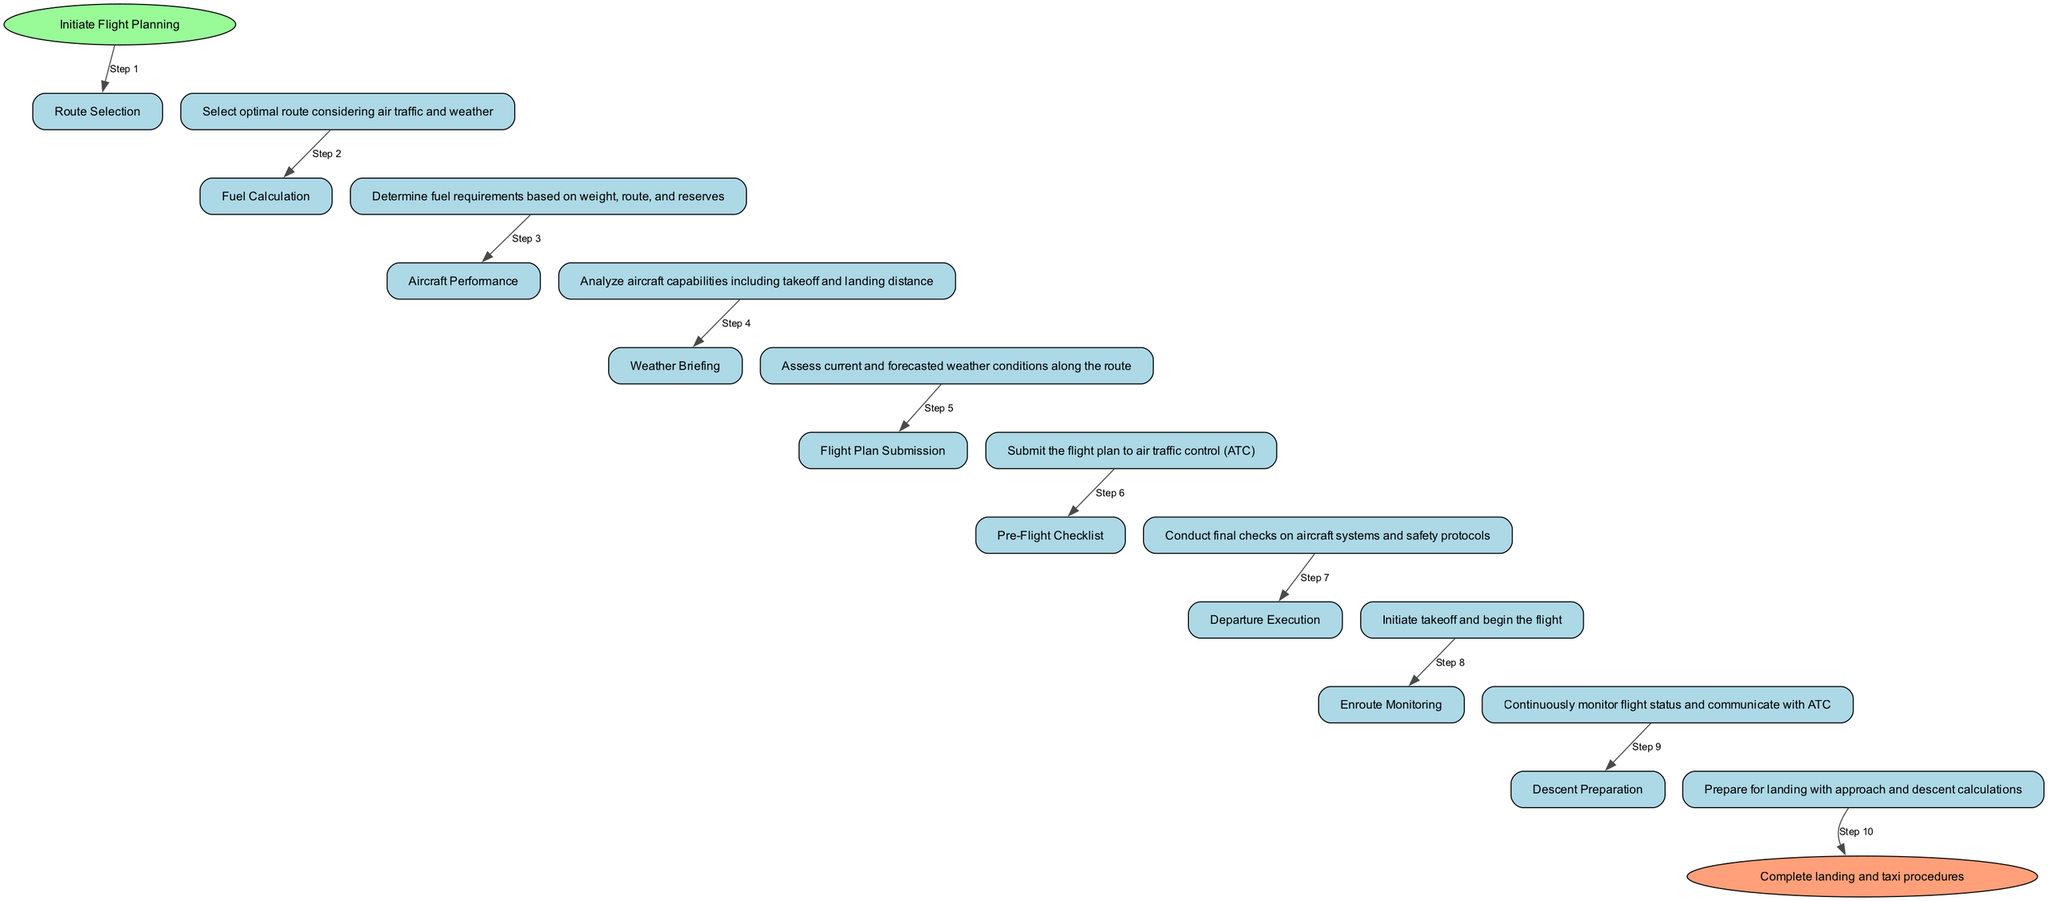What is the starting step in the flight planning workflow? The starting step is indicated in the diagram as "Start." It is the first node in the flow that initiates the flight planning process.
Answer: Initiate Flight Planning Which step comes after "Aircraft Performance"? The diagram shows "Weather Briefing" as the direct successor to "Aircraft Performance," indicating the next step in the workflow.
Answer: Weather Briefing How many steps are there in the flight planning workflow? By counting the nodes in the diagram from "Start" to "Arrival," there are a total of 11 steps in the workflow, each representing a significant action or decision point.
Answer: 11 What is the final step of the flight planning workflow? The final step is indicated as "Arrival," which culminates the entire flight planning process with completion of landing and taxi procedures.
Answer: Arrival What is the main action involved in the "Pre-Flight Checklist" step? The main action is to conduct final checks on aircraft systems and safety protocols, ensuring everything is ready for departure.
Answer: Conduct final checks What is the relationship between "Fuel Calculation" and "Weather Briefing"? "Fuel Calculation" precedes "Weather Briefing" in the flow, meaning the fuel requirements are calculated before assessing current and forecasted weather conditions.
Answer: Sequential relationship Which step involves submitting the flight plan? The diagram shows "Flight Plan Submission" as the step where the flight plan is submitted to air traffic control (ATC), indicating a crucial communication task before departure.
Answer: Flight Plan Submission How does "Descent Preparation" relate to "Enroute Monitoring"? "Enroute Monitoring" comes before "Descent Preparation," suggesting that continuous monitoring of flight status leads into preparations for landing maneuvers.
Answer: Prior step What is the overall purpose of the flight planning workflow as depicted? The workflow outlines a structured process from initiation to completion of a flight, covering all crucial steps to ensure safety and efficiency from departure to arrival.
Answer: Structured process 